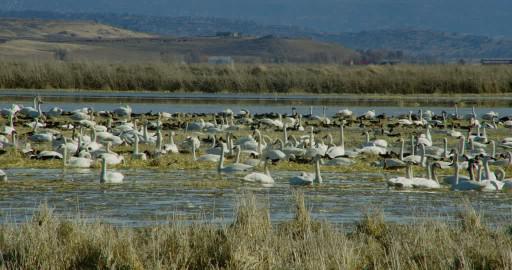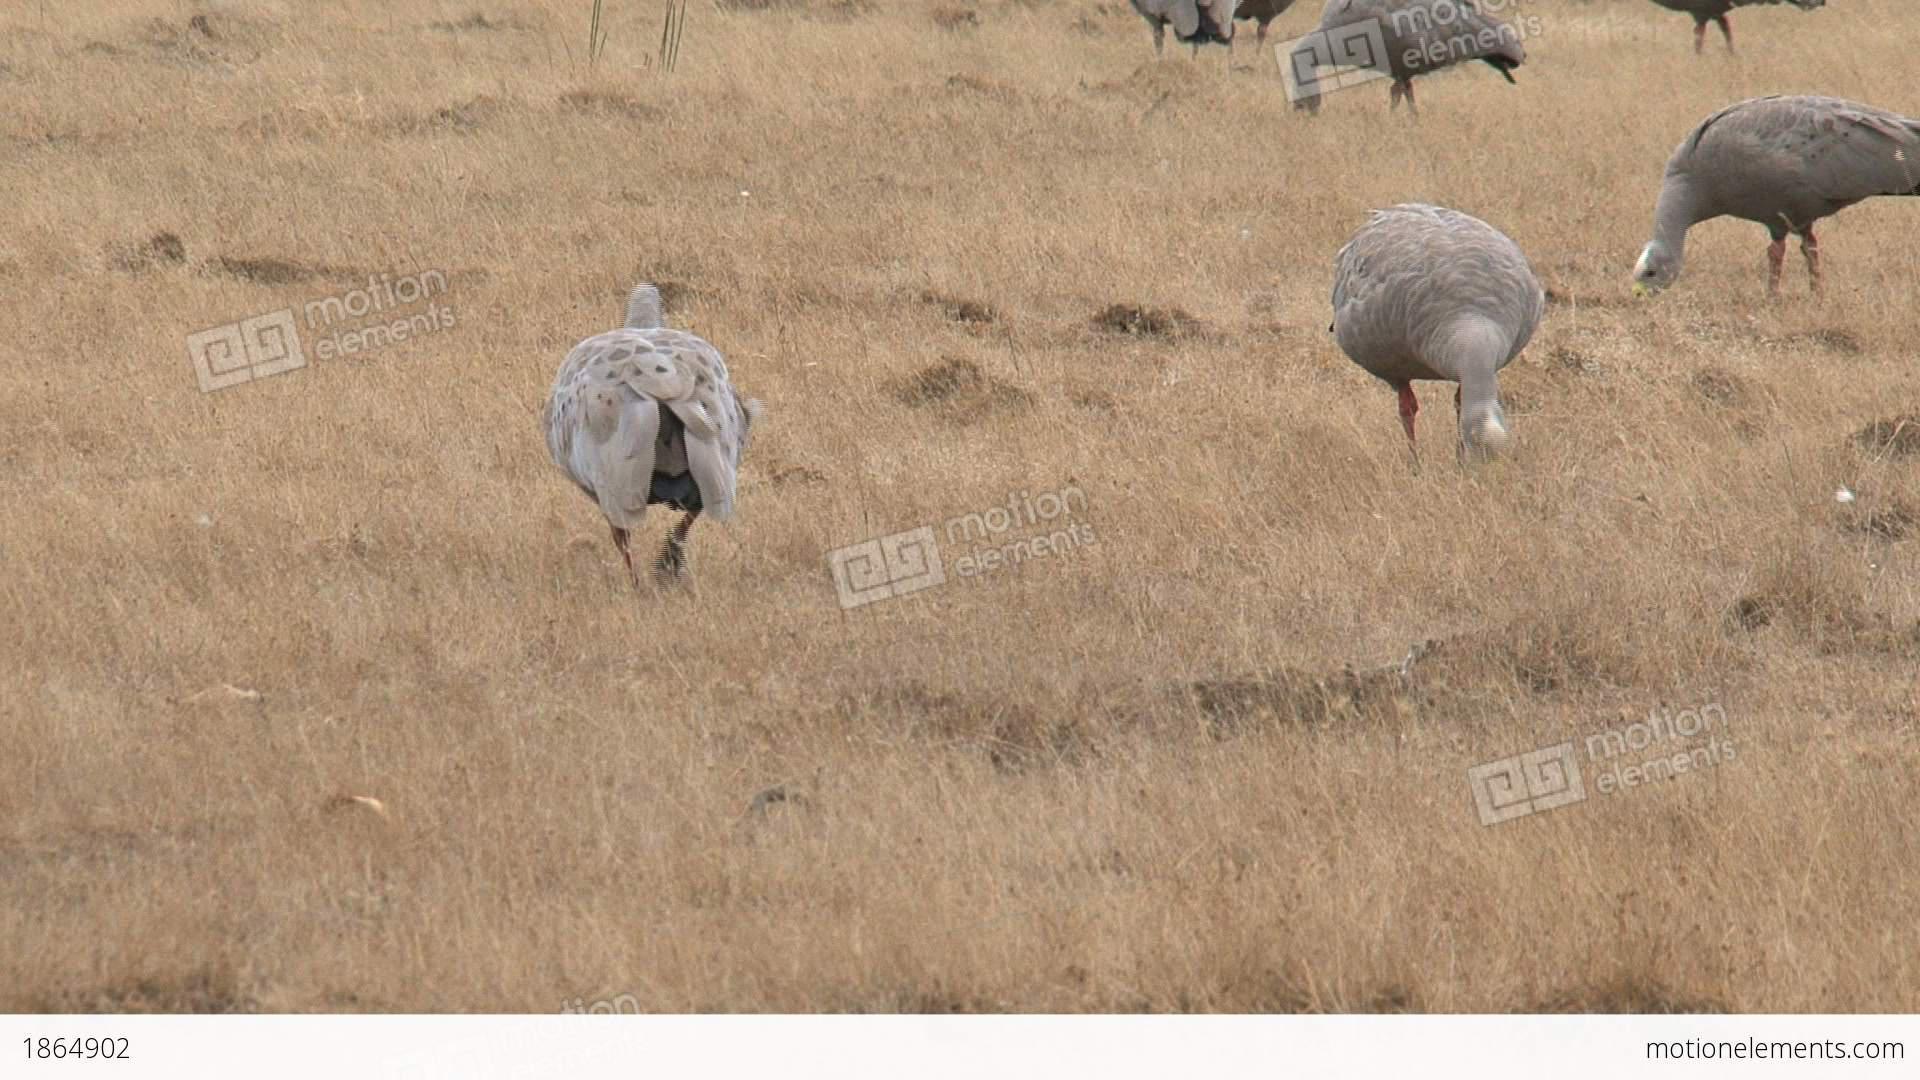The first image is the image on the left, the second image is the image on the right. Given the left and right images, does the statement "One of the images in the pair shows a flock of canada geese." hold true? Answer yes or no. No. 